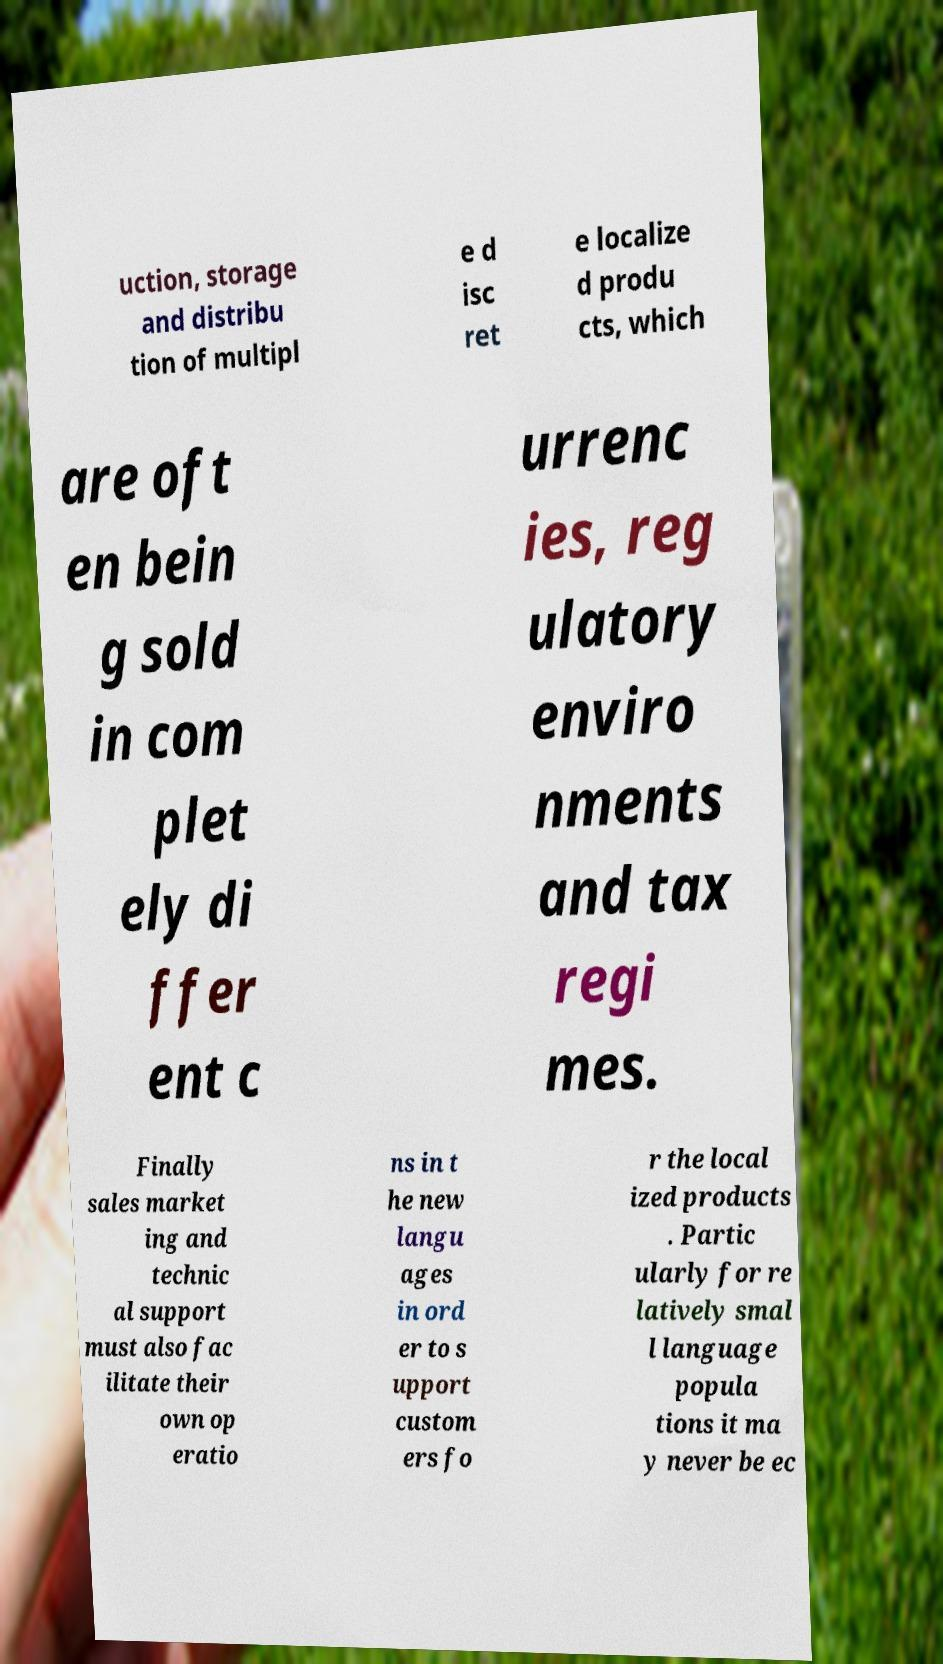Please read and relay the text visible in this image. What does it say? uction, storage and distribu tion of multipl e d isc ret e localize d produ cts, which are oft en bein g sold in com plet ely di ffer ent c urrenc ies, reg ulatory enviro nments and tax regi mes. Finally sales market ing and technic al support must also fac ilitate their own op eratio ns in t he new langu ages in ord er to s upport custom ers fo r the local ized products . Partic ularly for re latively smal l language popula tions it ma y never be ec 